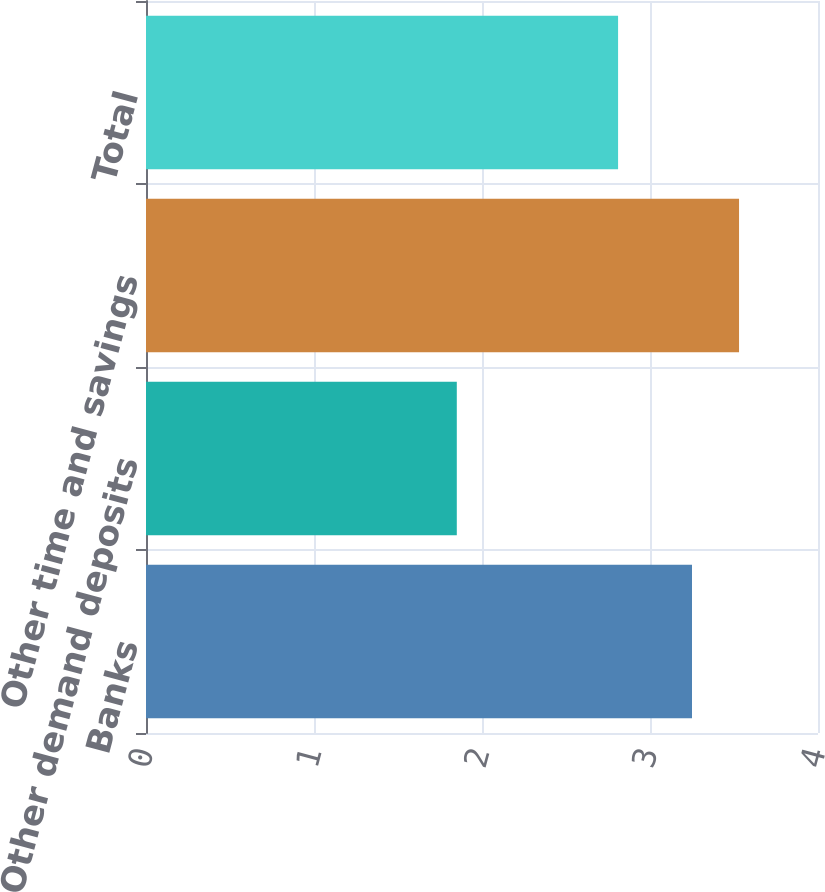Convert chart to OTSL. <chart><loc_0><loc_0><loc_500><loc_500><bar_chart><fcel>Banks<fcel>Other demand deposits<fcel>Other time and savings<fcel>Total<nl><fcel>3.25<fcel>1.85<fcel>3.53<fcel>2.81<nl></chart> 